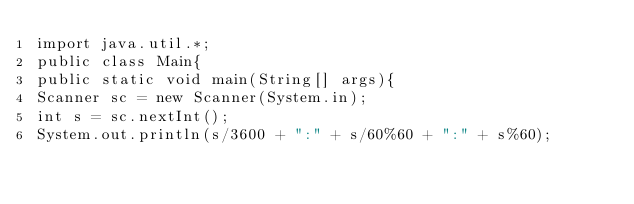<code> <loc_0><loc_0><loc_500><loc_500><_Java_>import java.util.*;
public class Main{
public static void main(String[] args){
Scanner sc = new Scanner(System.in);
int s = sc.nextInt();
System.out.println(s/3600 + ":" + s/60%60 + ":" + s%60);</code> 